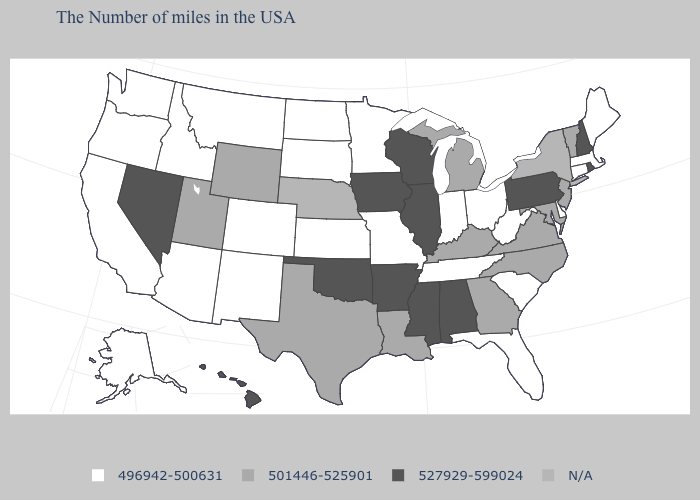What is the value of Tennessee?
Quick response, please. 496942-500631. Name the states that have a value in the range 527929-599024?
Give a very brief answer. Rhode Island, New Hampshire, Pennsylvania, Alabama, Wisconsin, Illinois, Mississippi, Arkansas, Iowa, Oklahoma, Nevada, Hawaii. What is the value of Rhode Island?
Answer briefly. 527929-599024. Which states hav the highest value in the West?
Write a very short answer. Nevada, Hawaii. Does the map have missing data?
Be succinct. Yes. Which states have the highest value in the USA?
Be succinct. Rhode Island, New Hampshire, Pennsylvania, Alabama, Wisconsin, Illinois, Mississippi, Arkansas, Iowa, Oklahoma, Nevada, Hawaii. Name the states that have a value in the range N/A?
Be succinct. New York, Nebraska. Does Arizona have the highest value in the USA?
Concise answer only. No. Among the states that border Florida , which have the lowest value?
Short answer required. Georgia. Which states have the lowest value in the Northeast?
Give a very brief answer. Maine, Massachusetts, Connecticut. Name the states that have a value in the range 501446-525901?
Keep it brief. Vermont, New Jersey, Maryland, Virginia, North Carolina, Georgia, Michigan, Kentucky, Louisiana, Texas, Wyoming, Utah. What is the value of North Carolina?
Short answer required. 501446-525901. Name the states that have a value in the range N/A?
Be succinct. New York, Nebraska. What is the value of Texas?
Write a very short answer. 501446-525901. 